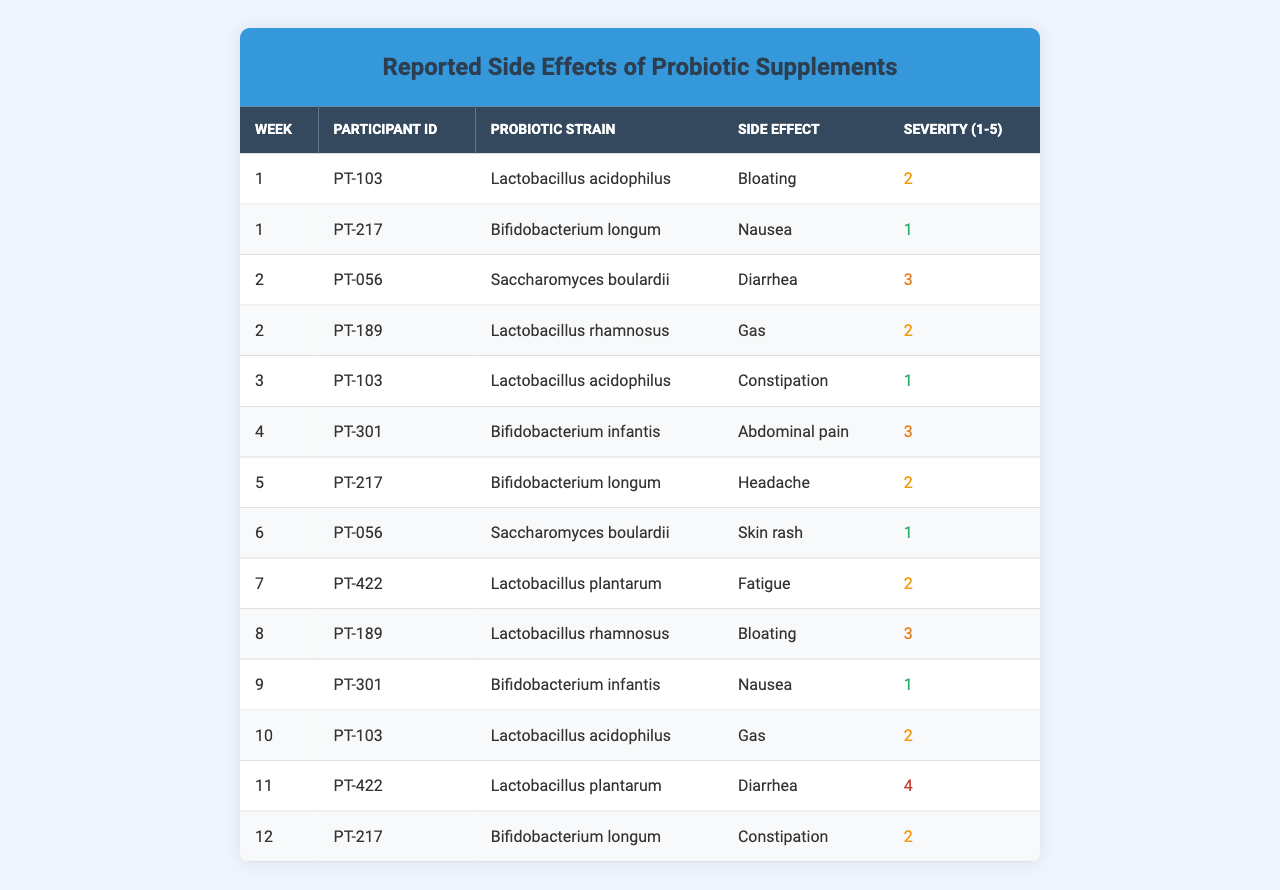What side effect was reported by Participant ID PT-217? By looking at the row corresponding to Participant ID PT-217, I can see that the side effect reported is "Nausea."
Answer: Nausea How many participants reported a skin rash? The table shows that only one participant, PT-056, reported a skin rash, indicated in Week 6.
Answer: 1 What was the severity rating for the abdominal pain reported? The table indicates that the severity for abdominal pain (reported by PT-301 in Week 4) is rated as 3.
Answer: 3 Which probiotic strain had the highest reported severity of side effects? The highest severity reported was 4, listed under Participant ID PT-422 with the side effect of diarrhea in Week 11, while no other strains showed a severity of 4.
Answer: Lactobacillus plantarum How many different side effects were reported at Week 2? The data for Week 2 shows two side effects: "Diarrhea" and "Gas" reported by PT-056 and PT-189, respectively.
Answer: 2 Was there any instance of fatigue reported, and if so, when? Yes, fatigue was reported by PT-422 during Week 7 as recorded in the table.
Answer: Yes, Week 7 What is the average severity of all reported side effects? To calculate the average, add the severity ratings (2 + 1 + 3 + 2 + 1 + 3 + 2 + 1 + 4 + 2) = 22, then divide by the number of entries (10): 22/10 = 2.2.
Answer: 2.2 Which participant had the highest severity rating and what was the side effect? The highest severity rating in the table is a 4, which corresponds to Participant ID PT-422 who reported diarrhea in Week 11.
Answer: PT-422, Diarrhea What total number of participants reported constipation during the trial? Looking through the table, the reports of constipation came from PT-103 in Week 3 and PT-217 in Week 12, totaling two participants.
Answer: 2 Did any participant report bloating more than once? Yes, PT-103 reported bloating in Week 1, and PT-189 reported it again in Week 8, showing that there are multiple instances of bloating reported by different participants.
Answer: Yes What percentage of reported side effects were rated as severity level 2? There are 4 instances of severity level 2 (PT-103 in Week 1, PT-217 in Week 5, PT-189 in Week 8, and PT-217 in Week 12) out of a total of 10 reported side effects. The percentage is (4/10)*100 = 40%.
Answer: 40% 